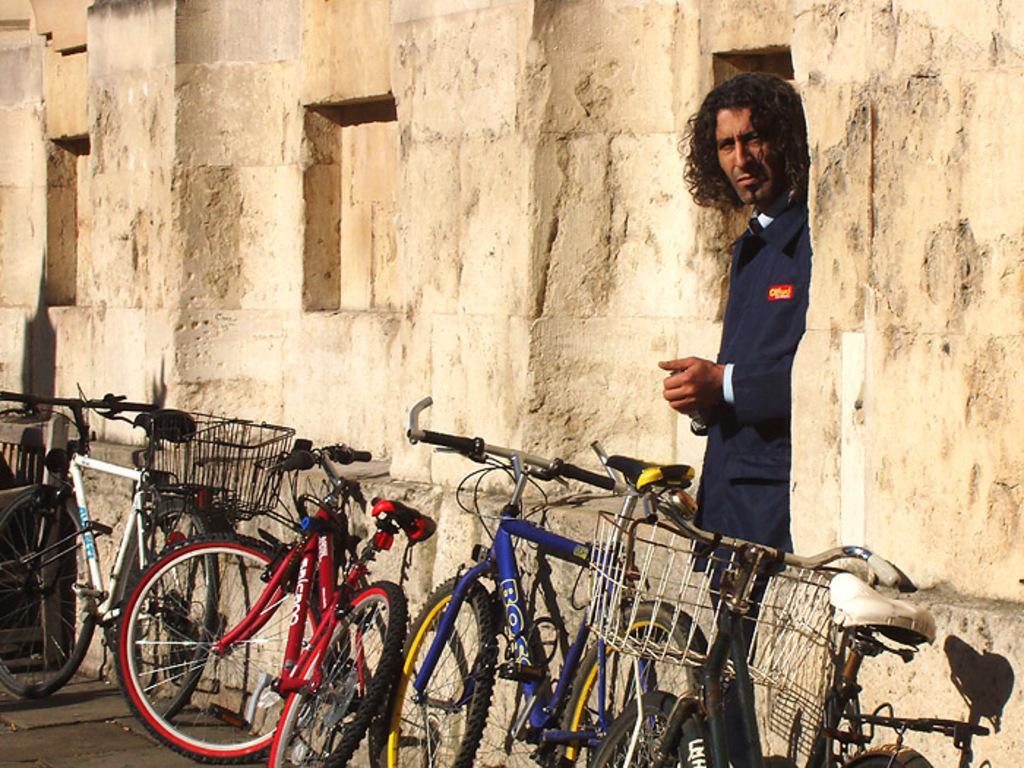In one or two sentences, can you explain what this image depicts? In this image we can see bicycles on the road, a man standing on the floor and a wall build with cobblestones. 